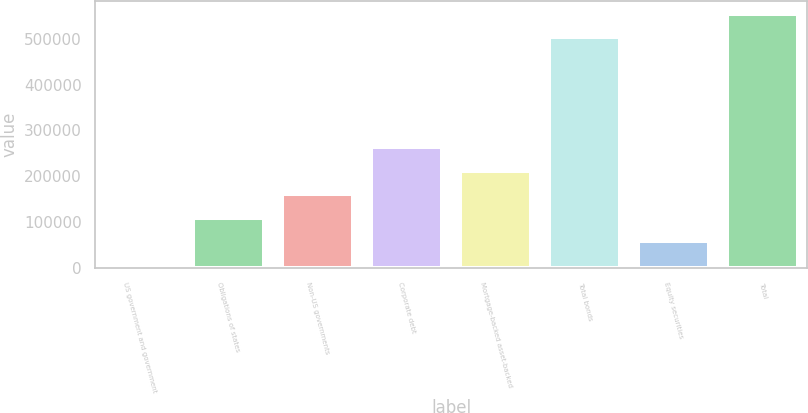Convert chart to OTSL. <chart><loc_0><loc_0><loc_500><loc_500><bar_chart><fcel>US government and government<fcel>Obligations of states<fcel>Non-US governments<fcel>Corporate debt<fcel>Mortgage-backed asset-backed<fcel>Total bonds<fcel>Equity securities<fcel>Total<nl><fcel>7748<fcel>110033<fcel>161176<fcel>263462<fcel>212319<fcel>503380<fcel>58890.7<fcel>554523<nl></chart> 